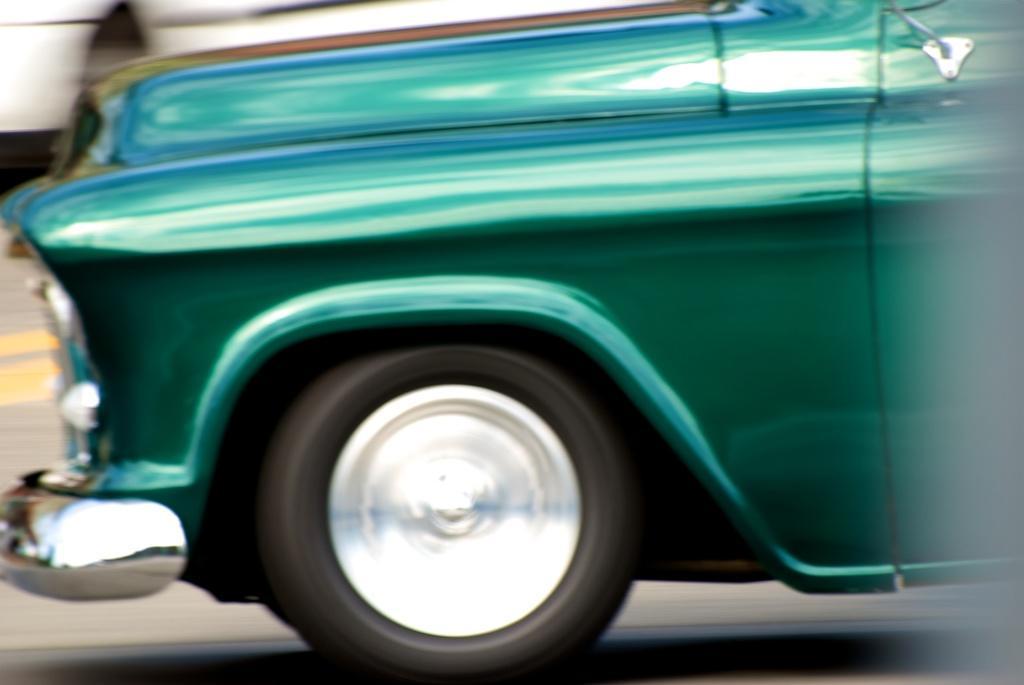How would you summarize this image in a sentence or two? In this picture we can see a car on the road. 